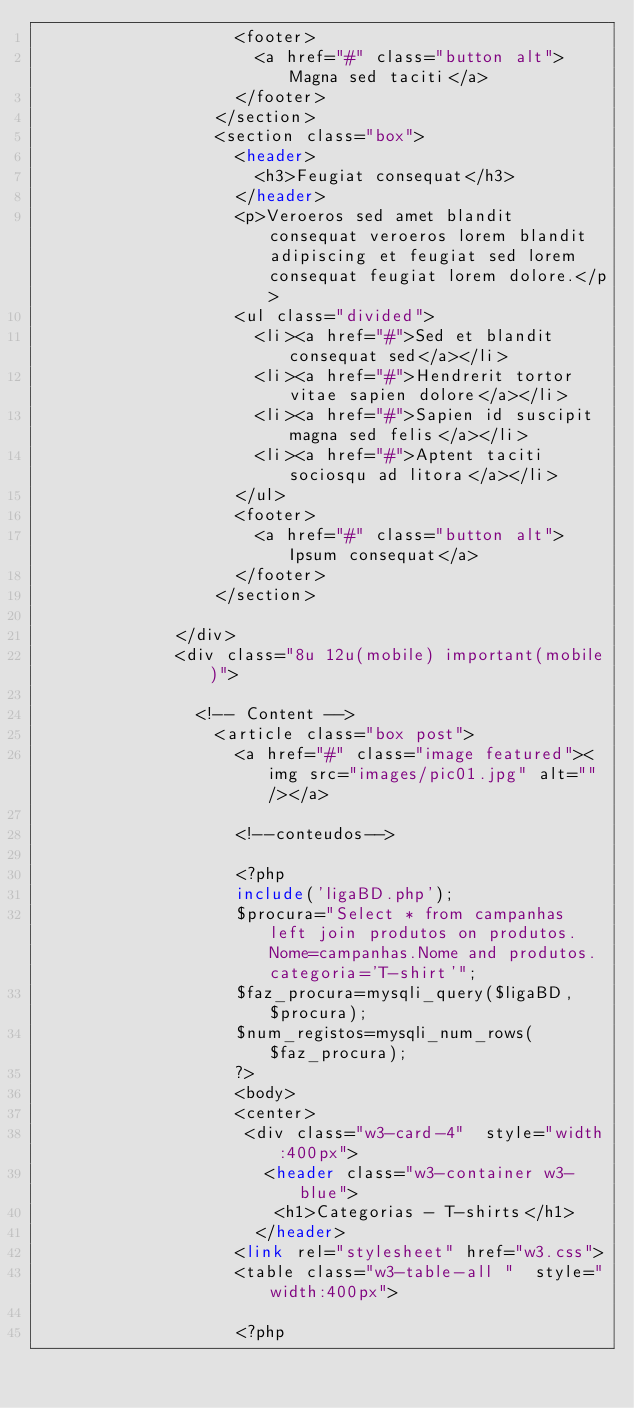<code> <loc_0><loc_0><loc_500><loc_500><_PHP_>										<footer>
											<a href="#" class="button alt">Magna sed taciti</a>
										</footer>
									</section>
									<section class="box">
										<header>
											<h3>Feugiat consequat</h3>
										</header>
										<p>Veroeros sed amet blandit consequat veroeros lorem blandit adipiscing et feugiat sed lorem consequat feugiat lorem dolore.</p>
										<ul class="divided">
											<li><a href="#">Sed et blandit consequat sed</a></li>
											<li><a href="#">Hendrerit tortor vitae sapien dolore</a></li>
											<li><a href="#">Sapien id suscipit magna sed felis</a></li>
											<li><a href="#">Aptent taciti sociosqu ad litora</a></li>
										</ul>
										<footer>
											<a href="#" class="button alt">Ipsum consequat</a>
										</footer>
									</section>

							</div>
							<div class="8u 12u(mobile) important(mobile)">

								<!-- Content -->
									<article class="box post">
										<a href="#" class="image featured"><img src="images/pic01.jpg" alt="" /></a>
										
										<!--conteudos-->
										
										<?php
										include('ligaBD.php');
										$procura="Select * from campanhas left join produtos on produtos.Nome=campanhas.Nome and produtos.categoria='T-shirt'";
										$faz_procura=mysqli_query($ligaBD,$procura);
										$num_registos=mysqli_num_rows($faz_procura);
										?>
										<body>
										<center>
										 <div class="w3-card-4"  style="width:400px">
											 <header class="w3-container w3-blue">
											  <h1>Categorias - T-shirts</h1>
											</header>
										<link rel="stylesheet" href="w3.css">
										<table class="w3-table-all "  style="width:400px">

										<?php</code> 